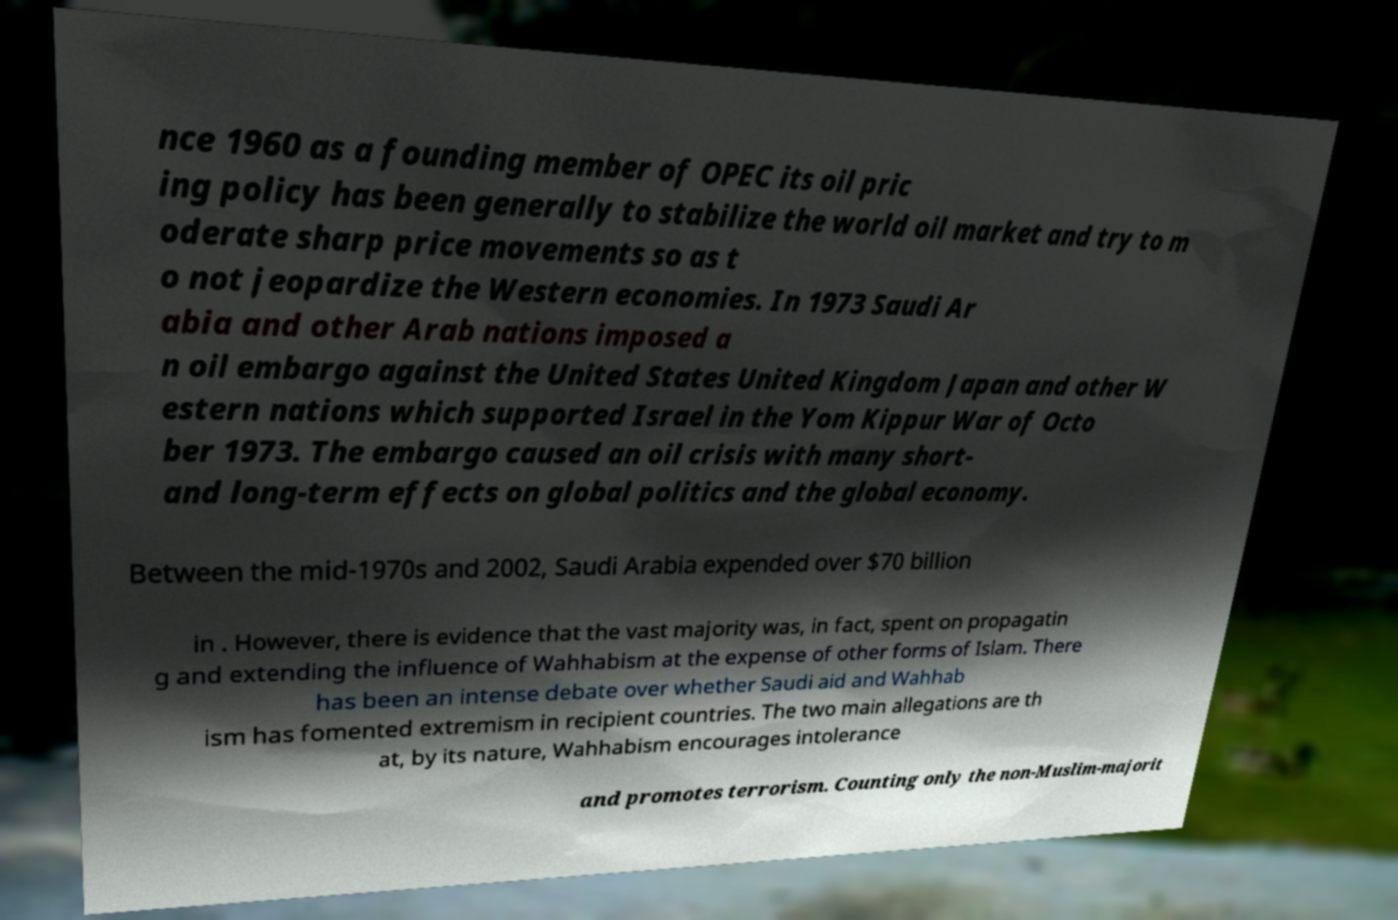For documentation purposes, I need the text within this image transcribed. Could you provide that? nce 1960 as a founding member of OPEC its oil pric ing policy has been generally to stabilize the world oil market and try to m oderate sharp price movements so as t o not jeopardize the Western economies. In 1973 Saudi Ar abia and other Arab nations imposed a n oil embargo against the United States United Kingdom Japan and other W estern nations which supported Israel in the Yom Kippur War of Octo ber 1973. The embargo caused an oil crisis with many short- and long-term effects on global politics and the global economy. Between the mid-1970s and 2002, Saudi Arabia expended over $70 billion in . However, there is evidence that the vast majority was, in fact, spent on propagatin g and extending the influence of Wahhabism at the expense of other forms of Islam. There has been an intense debate over whether Saudi aid and Wahhab ism has fomented extremism in recipient countries. The two main allegations are th at, by its nature, Wahhabism encourages intolerance and promotes terrorism. Counting only the non-Muslim-majorit 